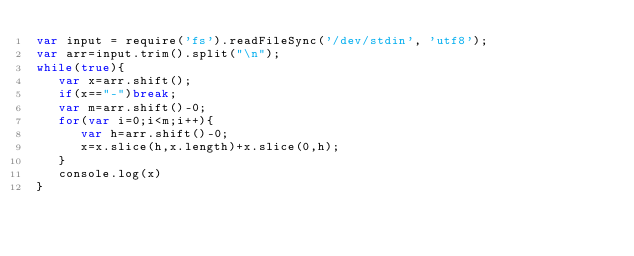Convert code to text. <code><loc_0><loc_0><loc_500><loc_500><_JavaScript_>var input = require('fs').readFileSync('/dev/stdin', 'utf8');
var arr=input.trim().split("\n");
while(true){
   var x=arr.shift();
   if(x=="-")break;
   var m=arr.shift()-0;
   for(var i=0;i<m;i++){
      var h=arr.shift()-0;
      x=x.slice(h,x.length)+x.slice(0,h);
   }
   console.log(x)
}</code> 